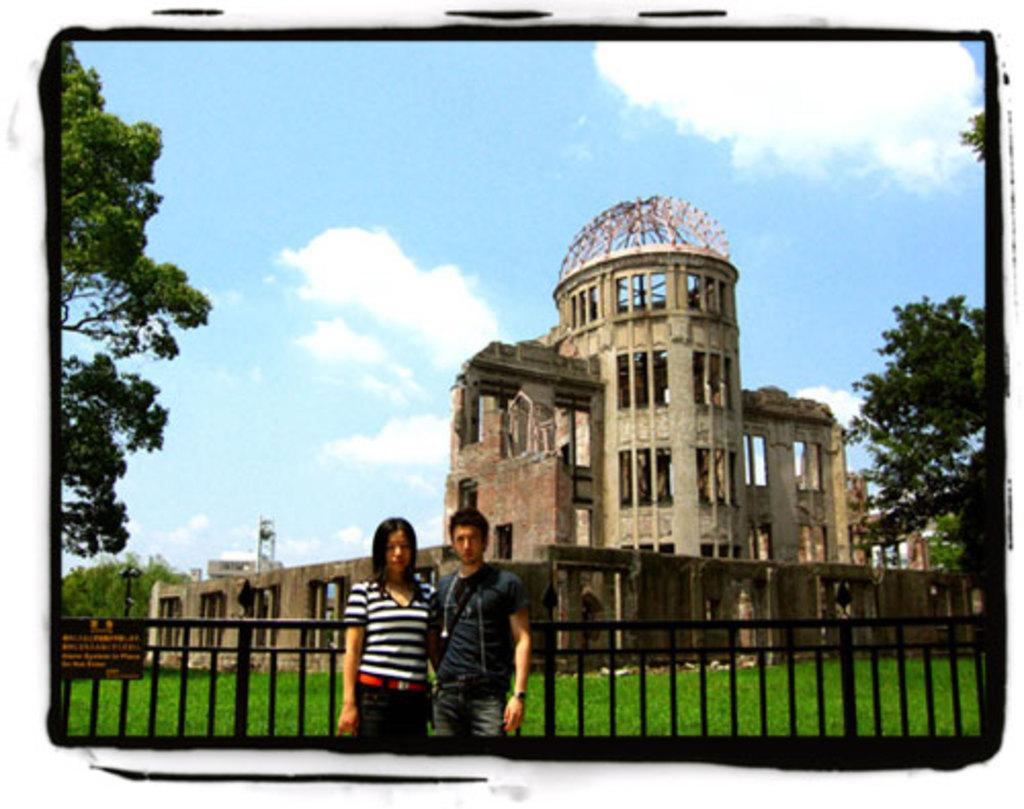How many people are in the image? There are two persons in the image. What can be seen in the background of the image? There is a building in the background of the image. What is located to the left of the image? There is a tree to the left of the image. What type of vegetation is at the bottom of the image? There is green grass at the bottom of the image. Can you tell me how many snails are crawling on the edge of the building in the image? There are no snails visible in the image, and therefore no such activity can be observed. 